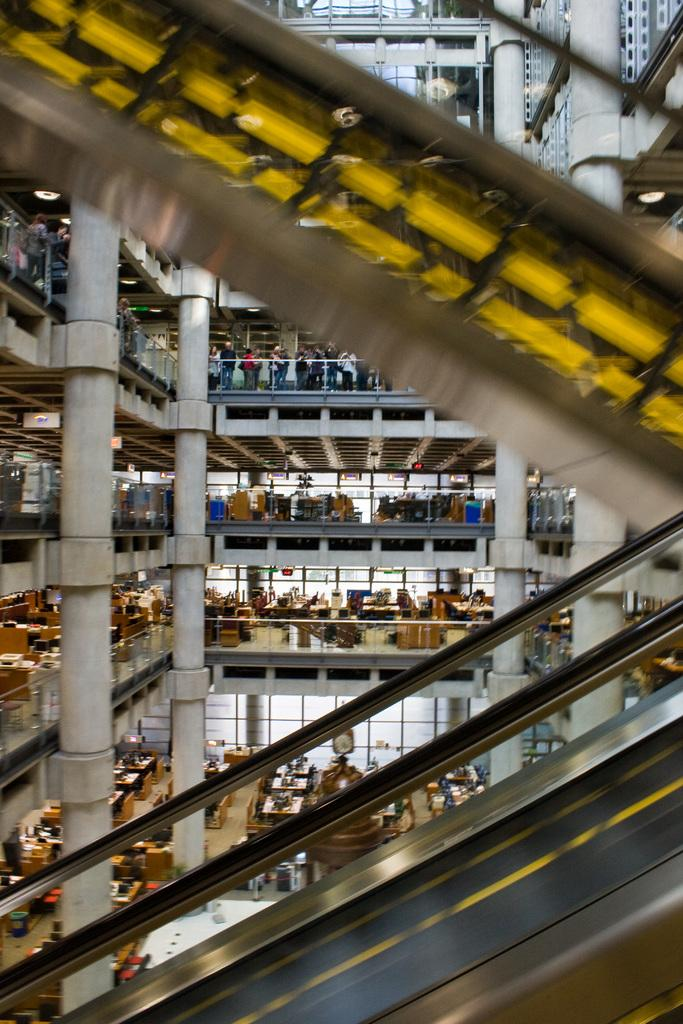What type of location is depicted in the image? The image is of the inside of a building. Can you describe the people in the image? There is a group of people in the image. What structural elements can be seen in the image? Iron rods are present in the image. What furniture is visible in the image? There are tables and chairs in the image. What lighting is present in the image? Lights are present in the image. What type of transportation is featured in the image? Escalators are in the image. What type of tank is visible in the image? There is no tank present in the image; it depicts the inside of a building with people, iron rods, tables, chairs, lights, and escalators. 